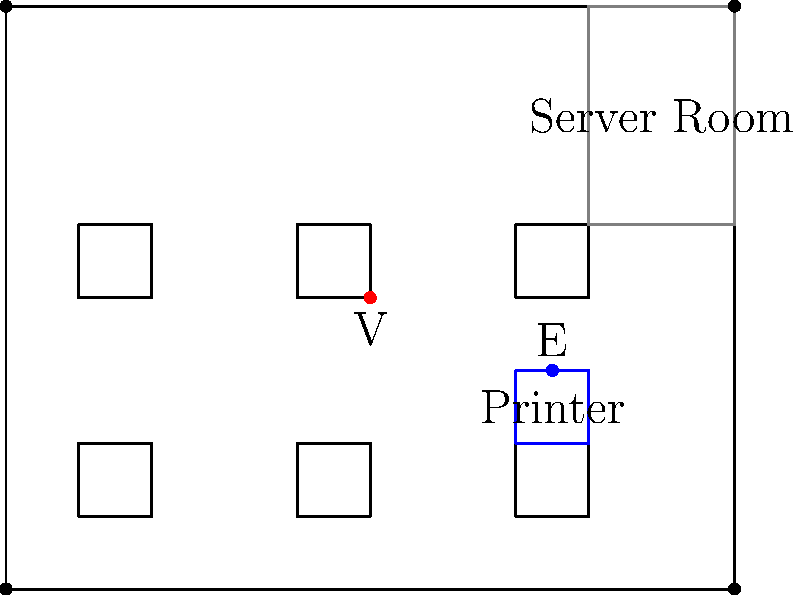In the given office layout, which scenario presents the highest risk of a potential trade secret breach? To identify the highest risk of a potential trade secret breach, let's analyze the office layout and the positions of individuals:

1. Office layout:
   - The office has six desks arranged in two rows of three.
   - There's a server room in the top right corner.
   - A printer is located near the center-right of the office.
   - Security cameras are placed in all four corners of the office.

2. Individuals present:
   - A visitor (V) is standing in the center of the office.
   - An employee (E) is positioned near the printer.

3. Risk assessment:
   a) Server room: This is likely to contain sensitive information but appears to be secure and separate from the main office area.
   b) Desks: No immediate risks are visible at the desks.
   c) Printer: The employee near the printer poses a potential risk. Printers often handle sensitive documents, and the employee's proximity could allow for unauthorized access or viewing of confidential information.
   d) Visitor: The visitor's central position in the office is concerning. They have a clear view of multiple desks and the printer area, potentially allowing them to observe sensitive information or overhear confidential conversations.

4. Highest risk scenario:
   The visitor's presence in the center of the office presents the highest risk. Their position allows them to potentially:
   - View multiple computer screens or documents on desks
   - Overhear conversations between employees
   - Observe activities around the printer, including any documents being printed
   - Have an unobstructed view of a large portion of the office layout

While the employee near the printer also presents a risk, it's more controlled as they are likely authorized to be in that area. The visitor, however, has no clear reason to be in such a central, unrestricted position within the office.
Answer: Visitor in central office area 